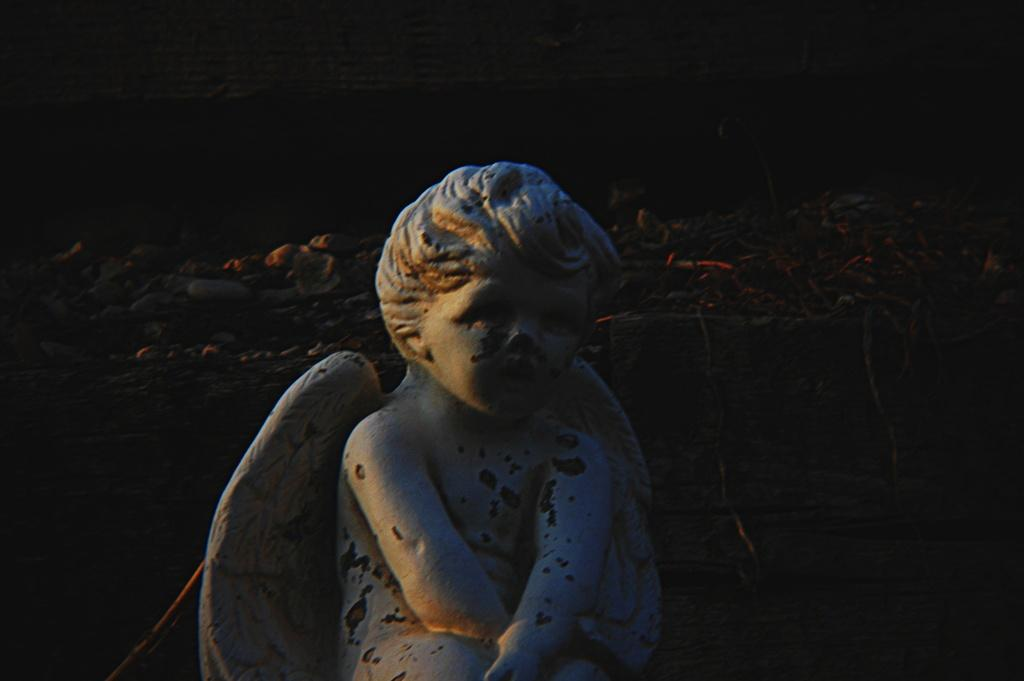What is the main subject of the image? The main subject of the image is a sculpture of a boy. What feature does the sculpture have? The sculpture has wings. What can be seen in the background of the image? There are rocks in the background of the image. What day of the week is depicted in the image? The image does not depict a day of the week; it features a sculpture of a boy with wings and rocks in the background. 